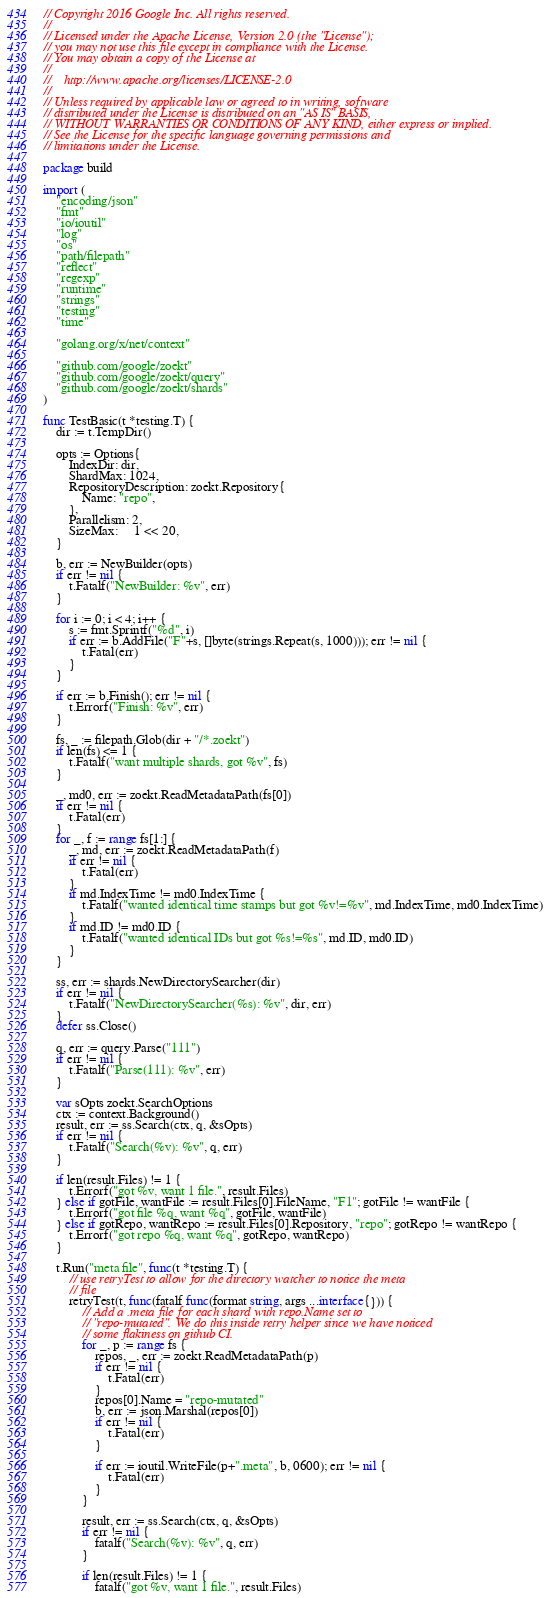Convert code to text. <code><loc_0><loc_0><loc_500><loc_500><_Go_>// Copyright 2016 Google Inc. All rights reserved.
//
// Licensed under the Apache License, Version 2.0 (the "License");
// you may not use this file except in compliance with the License.
// You may obtain a copy of the License at
//
//    http://www.apache.org/licenses/LICENSE-2.0
//
// Unless required by applicable law or agreed to in writing, software
// distributed under the License is distributed on an "AS IS" BASIS,
// WITHOUT WARRANTIES OR CONDITIONS OF ANY KIND, either express or implied.
// See the License for the specific language governing permissions and
// limitations under the License.

package build

import (
	"encoding/json"
	"fmt"
	"io/ioutil"
	"log"
	"os"
	"path/filepath"
	"reflect"
	"regexp"
	"runtime"
	"strings"
	"testing"
	"time"

	"golang.org/x/net/context"

	"github.com/google/zoekt"
	"github.com/google/zoekt/query"
	"github.com/google/zoekt/shards"
)

func TestBasic(t *testing.T) {
	dir := t.TempDir()

	opts := Options{
		IndexDir: dir,
		ShardMax: 1024,
		RepositoryDescription: zoekt.Repository{
			Name: "repo",
		},
		Parallelism: 2,
		SizeMax:     1 << 20,
	}

	b, err := NewBuilder(opts)
	if err != nil {
		t.Fatalf("NewBuilder: %v", err)
	}

	for i := 0; i < 4; i++ {
		s := fmt.Sprintf("%d", i)
		if err := b.AddFile("F"+s, []byte(strings.Repeat(s, 1000))); err != nil {
			t.Fatal(err)
		}
	}

	if err := b.Finish(); err != nil {
		t.Errorf("Finish: %v", err)
	}

	fs, _ := filepath.Glob(dir + "/*.zoekt")
	if len(fs) <= 1 {
		t.Fatalf("want multiple shards, got %v", fs)
	}

	_, md0, err := zoekt.ReadMetadataPath(fs[0])
	if err != nil {
		t.Fatal(err)
	}
	for _, f := range fs[1:] {
		_, md, err := zoekt.ReadMetadataPath(f)
		if err != nil {
			t.Fatal(err)
		}
		if md.IndexTime != md0.IndexTime {
			t.Fatalf("wanted identical time stamps but got %v!=%v", md.IndexTime, md0.IndexTime)
		}
		if md.ID != md0.ID {
			t.Fatalf("wanted identical IDs but got %s!=%s", md.ID, md0.ID)
		}
	}

	ss, err := shards.NewDirectorySearcher(dir)
	if err != nil {
		t.Fatalf("NewDirectorySearcher(%s): %v", dir, err)
	}
	defer ss.Close()

	q, err := query.Parse("111")
	if err != nil {
		t.Fatalf("Parse(111): %v", err)
	}

	var sOpts zoekt.SearchOptions
	ctx := context.Background()
	result, err := ss.Search(ctx, q, &sOpts)
	if err != nil {
		t.Fatalf("Search(%v): %v", q, err)
	}

	if len(result.Files) != 1 {
		t.Errorf("got %v, want 1 file.", result.Files)
	} else if gotFile, wantFile := result.Files[0].FileName, "F1"; gotFile != wantFile {
		t.Errorf("got file %q, want %q", gotFile, wantFile)
	} else if gotRepo, wantRepo := result.Files[0].Repository, "repo"; gotRepo != wantRepo {
		t.Errorf("got repo %q, want %q", gotRepo, wantRepo)
	}

	t.Run("meta file", func(t *testing.T) {
		// use retryTest to allow for the directory watcher to notice the meta
		// file
		retryTest(t, func(fatalf func(format string, args ...interface{})) {
			// Add a .meta file for each shard with repo.Name set to
			// "repo-mutated". We do this inside retry helper since we have noticed
			// some flakiness on github CI.
			for _, p := range fs {
				repos, _, err := zoekt.ReadMetadataPath(p)
				if err != nil {
					t.Fatal(err)
				}
				repos[0].Name = "repo-mutated"
				b, err := json.Marshal(repos[0])
				if err != nil {
					t.Fatal(err)
				}

				if err := ioutil.WriteFile(p+".meta", b, 0600); err != nil {
					t.Fatal(err)
				}
			}

			result, err := ss.Search(ctx, q, &sOpts)
			if err != nil {
				fatalf("Search(%v): %v", q, err)
			}

			if len(result.Files) != 1 {
				fatalf("got %v, want 1 file.", result.Files)</code> 